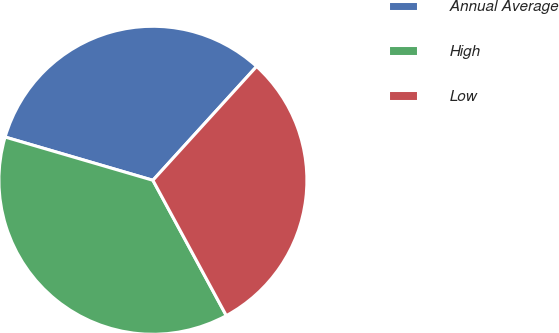Convert chart. <chart><loc_0><loc_0><loc_500><loc_500><pie_chart><fcel>Annual Average<fcel>High<fcel>Low<nl><fcel>32.23%<fcel>37.44%<fcel>30.33%<nl></chart> 